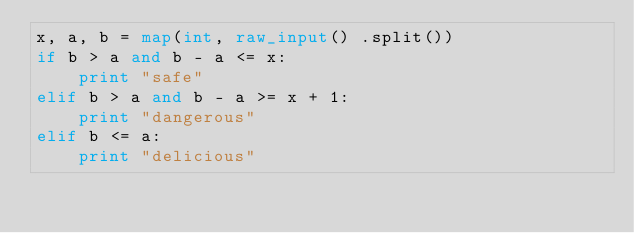<code> <loc_0><loc_0><loc_500><loc_500><_Python_>x, a, b = map(int, raw_input() .split())
if b > a and b - a <= x:
    print "safe"
elif b > a and b - a >= x + 1:
    print "dangerous"
elif b <= a:
    print "delicious"
</code> 